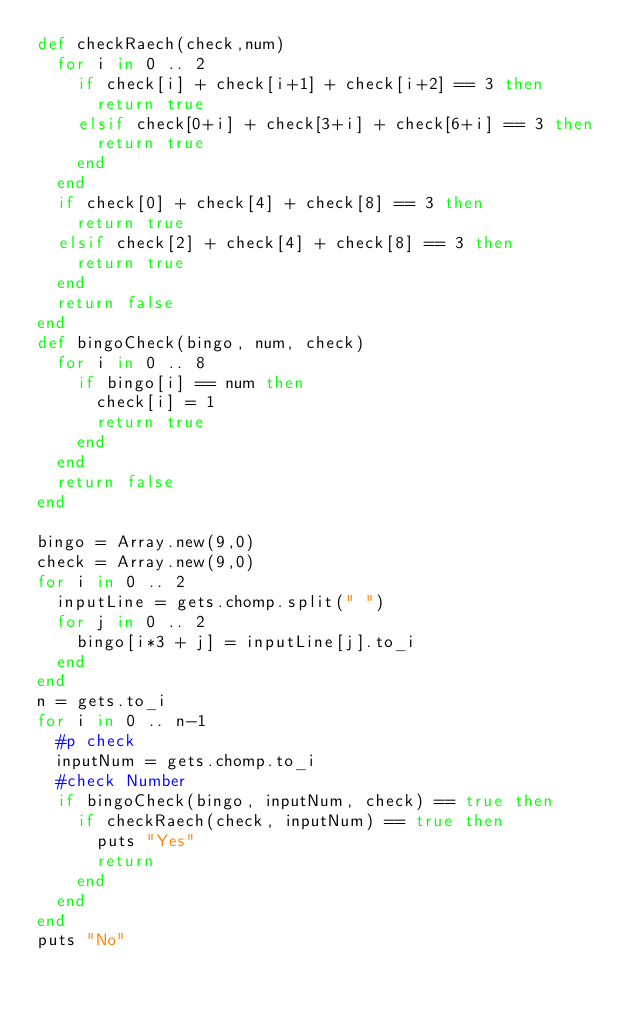Convert code to text. <code><loc_0><loc_0><loc_500><loc_500><_Ruby_>def checkRaech(check,num)
  for i in 0 .. 2
    if check[i] + check[i+1] + check[i+2] == 3 then
      return true
    elsif check[0+i] + check[3+i] + check[6+i] == 3 then
      return true
    end
  end
  if check[0] + check[4] + check[8] == 3 then
    return true
  elsif check[2] + check[4] + check[8] == 3 then
    return true
  end
  return false
end
def bingoCheck(bingo, num, check)
  for i in 0 .. 8
    if bingo[i] == num then
      check[i] = 1
      return true
    end
  end
  return false
end

bingo = Array.new(9,0)
check = Array.new(9,0)
for i in 0 .. 2 
  inputLine = gets.chomp.split(" ")
  for j in 0 .. 2
    bingo[i*3 + j] = inputLine[j].to_i
  end
end
n = gets.to_i
for i in 0 .. n-1
  #p check
  inputNum = gets.chomp.to_i
  #check Number
  if bingoCheck(bingo, inputNum, check) == true then
    if checkRaech(check, inputNum) == true then
      puts "Yes"
      return
    end
  end
end 
puts "No"
</code> 